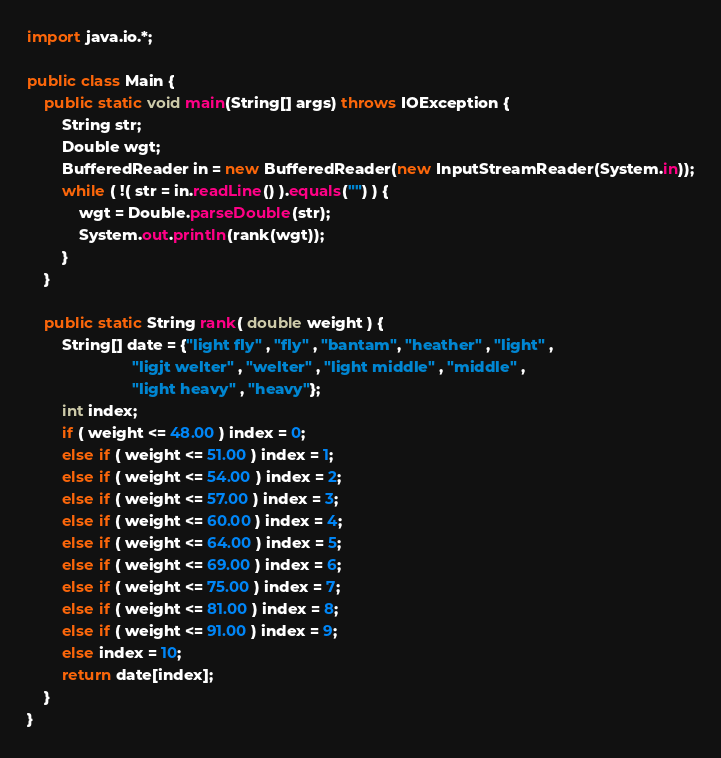<code> <loc_0><loc_0><loc_500><loc_500><_Java_>import java.io.*;

public class Main {
	public static void main(String[] args) throws IOException {
		String str;
		Double wgt;
		BufferedReader in = new BufferedReader(new InputStreamReader(System.in));
		while ( !( str = in.readLine() ).equals("") ) {
			wgt = Double.parseDouble(str);
			System.out.println(rank(wgt));
		}
	}
	
	public static String rank( double weight ) {
		String[] date = {"light fly" , "fly" , "bantam", "heather" , "light" ,
						"ligjt welter" , "welter" , "light middle" , "middle" ,
						"light heavy" , "heavy"};
		int index;
		if ( weight <= 48.00 ) index = 0; 
		else if ( weight <= 51.00 ) index = 1; 
		else if ( weight <= 54.00 ) index = 2; 
		else if ( weight <= 57.00 ) index = 3; 
		else if ( weight <= 60.00 ) index = 4; 
		else if ( weight <= 64.00 ) index = 5; 
		else if ( weight <= 69.00 ) index = 6; 
		else if ( weight <= 75.00 ) index = 7;
		else if ( weight <= 81.00 ) index = 8; 
		else if ( weight <= 91.00 ) index = 9;
		else index = 10;
		return date[index];
	}
}</code> 